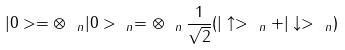<formula> <loc_0><loc_0><loc_500><loc_500>| 0 > = \otimes _ { \ n } | 0 > _ { \ n } = \otimes _ { \ n } \, \frac { 1 } { \sqrt { 2 } } ( | \uparrow > _ { \ n } + | \downarrow > _ { \ n } )</formula> 